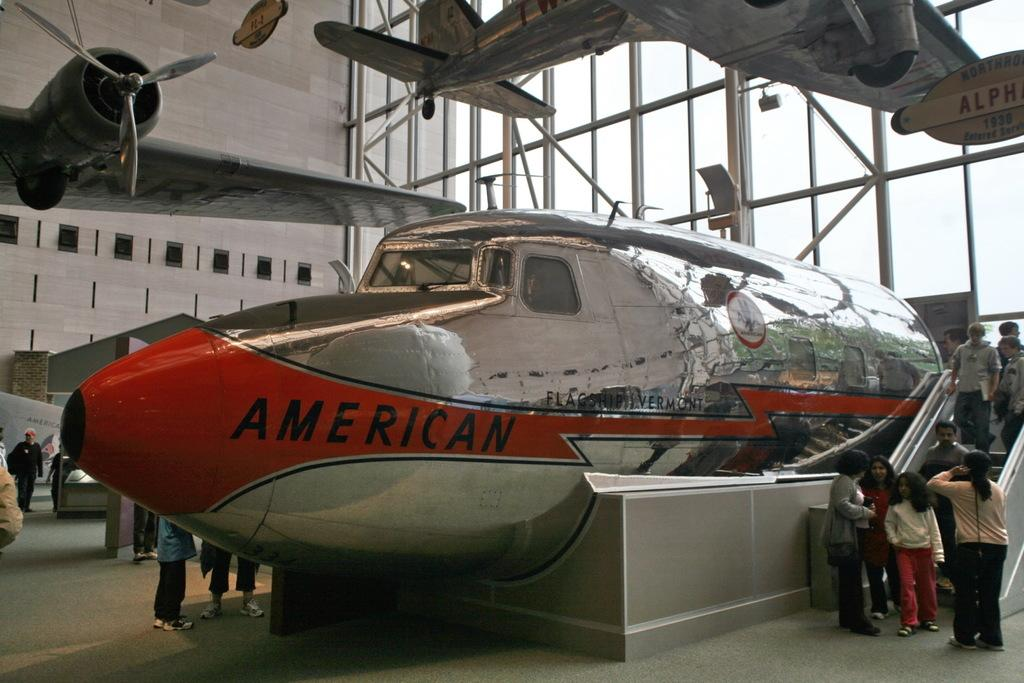Provide a one-sentence caption for the provided image. A silver plane that says American is on display in a museum. 